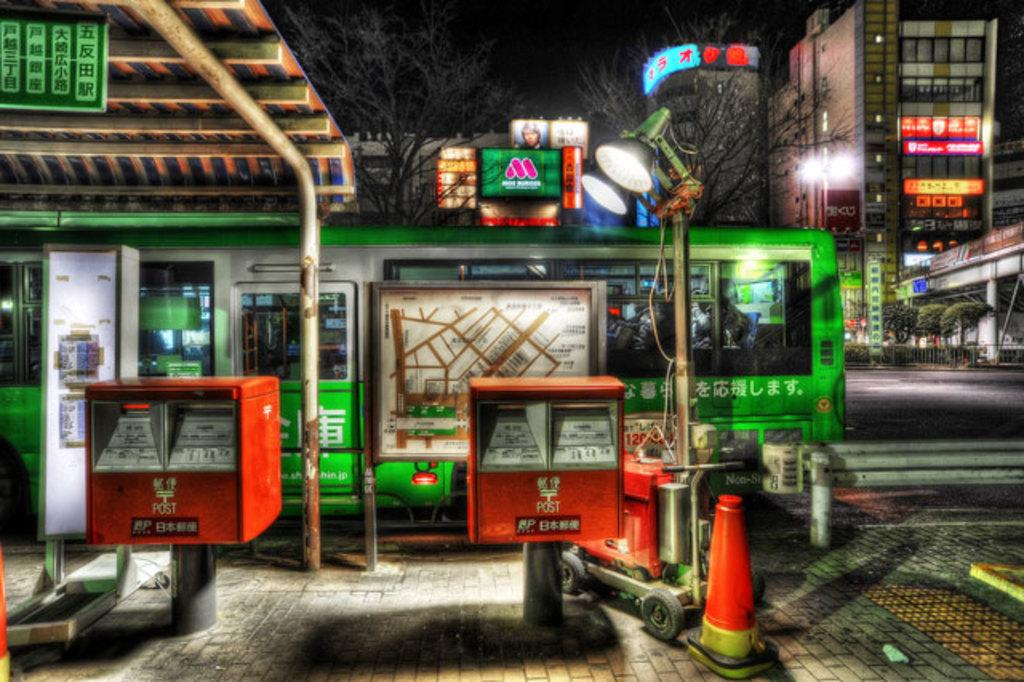<image>
Provide a brief description of the given image. Red machine that says POST on the bottom in yellow. 